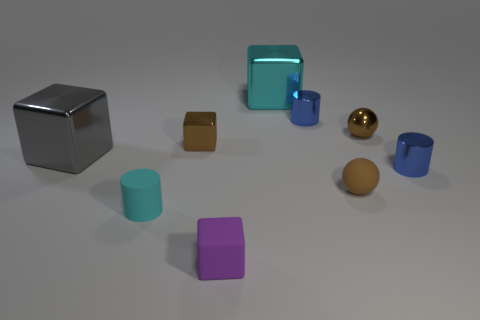What shape is the shiny thing that is the same color as the matte cylinder?
Ensure brevity in your answer.  Cube. How many large metal objects are in front of the tiny brown matte ball?
Keep it short and to the point. 0. Is the gray object the same shape as the big cyan shiny object?
Ensure brevity in your answer.  Yes. How many metal objects are both right of the tiny purple rubber block and to the left of the tiny cyan object?
Make the answer very short. 0. What number of objects are yellow metal objects or small things in front of the cyan cylinder?
Your response must be concise. 1. Is the number of tiny green blocks greater than the number of metal objects?
Keep it short and to the point. No. The tiny brown object in front of the gray thing has what shape?
Offer a terse response. Sphere. What number of other tiny metal objects are the same shape as the cyan shiny thing?
Offer a very short reply. 1. What size is the blue shiny thing that is behind the small brown shiny object that is left of the purple thing?
Ensure brevity in your answer.  Small. What number of purple things are tiny metallic balls or tiny rubber things?
Your answer should be compact. 1. 